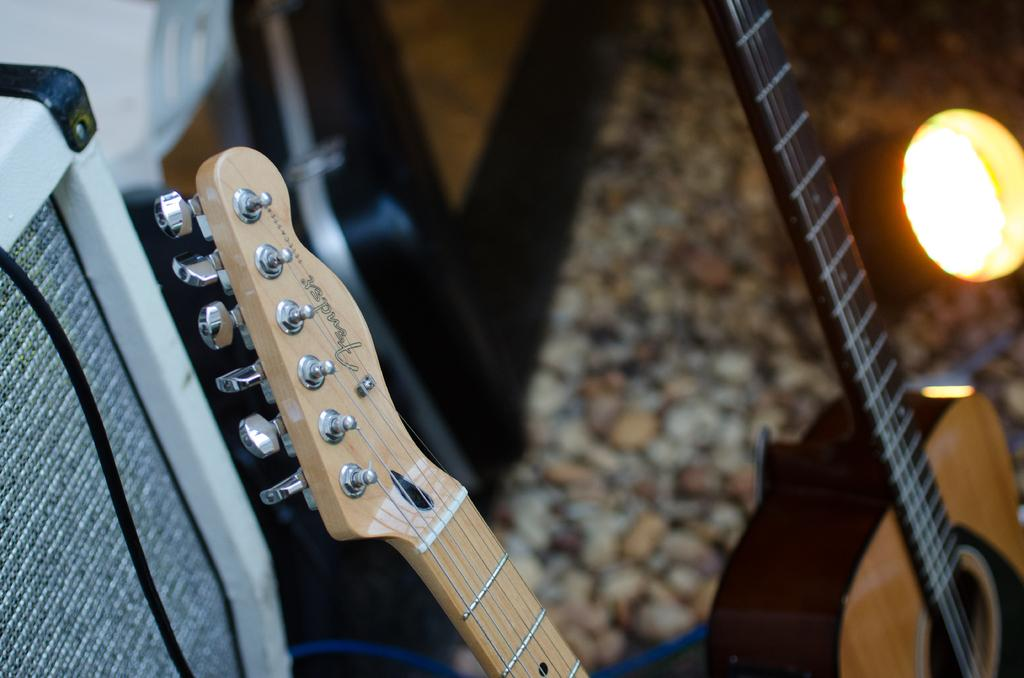How many guitars are present in the image? There are two guitars in the image. What are the colors of the guitars? One guitar is creme in color, and the other guitar is brown in color. What type of sugar is being used to play the guitars in the image? There is no sugar present in the image, and the guitars are not being played with any sugar. 